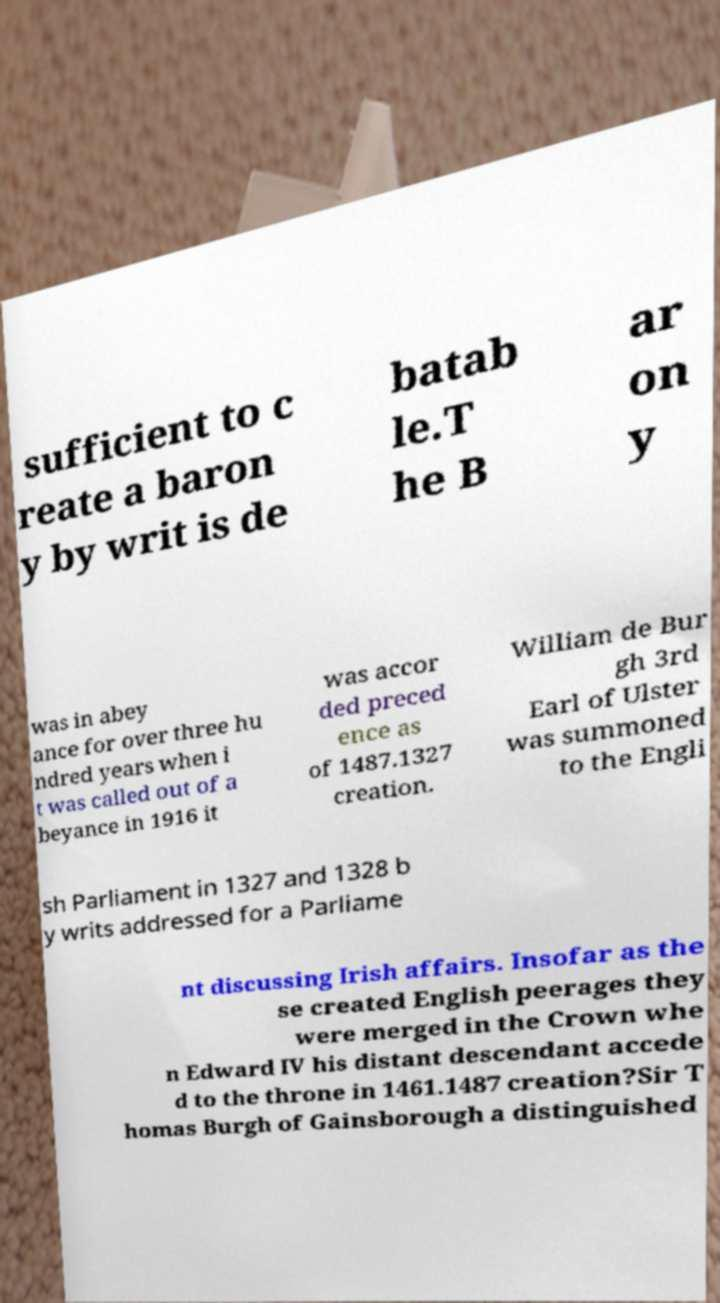I need the written content from this picture converted into text. Can you do that? sufficient to c reate a baron y by writ is de batab le.T he B ar on y was in abey ance for over three hu ndred years when i t was called out of a beyance in 1916 it was accor ded preced ence as of 1487.1327 creation. William de Bur gh 3rd Earl of Ulster was summoned to the Engli sh Parliament in 1327 and 1328 b y writs addressed for a Parliame nt discussing Irish affairs. Insofar as the se created English peerages they were merged in the Crown whe n Edward IV his distant descendant accede d to the throne in 1461.1487 creation?Sir T homas Burgh of Gainsborough a distinguished 